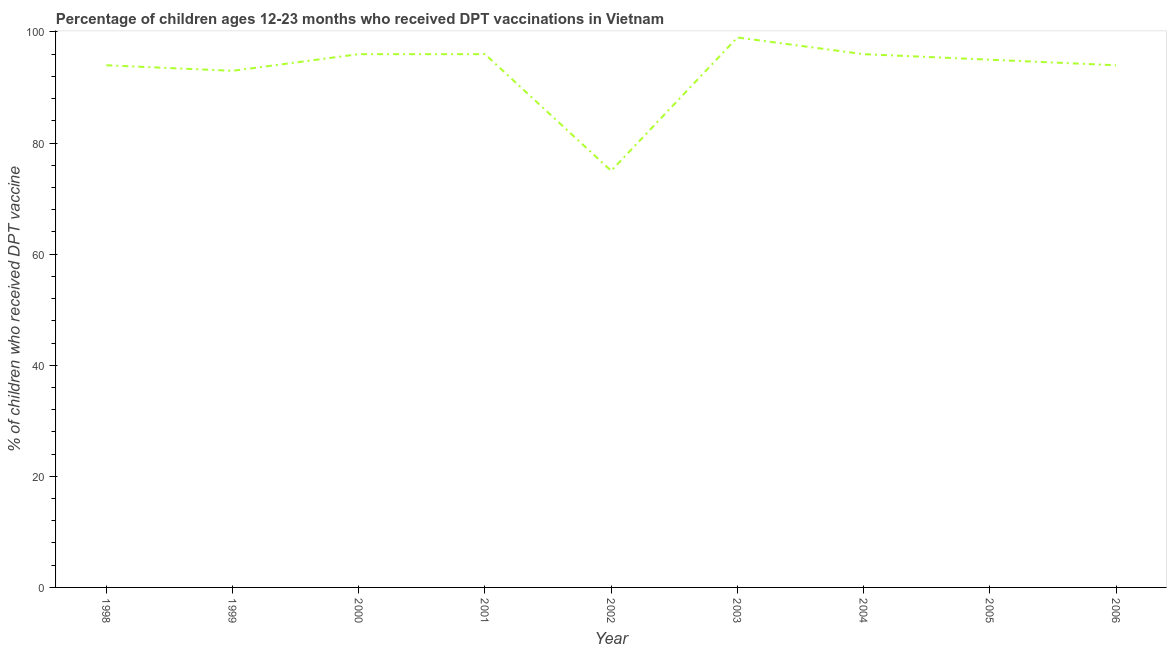What is the percentage of children who received dpt vaccine in 2002?
Offer a very short reply. 75. Across all years, what is the maximum percentage of children who received dpt vaccine?
Provide a short and direct response. 99. Across all years, what is the minimum percentage of children who received dpt vaccine?
Offer a very short reply. 75. In which year was the percentage of children who received dpt vaccine minimum?
Your response must be concise. 2002. What is the sum of the percentage of children who received dpt vaccine?
Keep it short and to the point. 838. What is the difference between the percentage of children who received dpt vaccine in 2001 and 2005?
Your answer should be very brief. 1. What is the average percentage of children who received dpt vaccine per year?
Ensure brevity in your answer.  93.11. What is the ratio of the percentage of children who received dpt vaccine in 1998 to that in 2001?
Your response must be concise. 0.98. Is the percentage of children who received dpt vaccine in 1999 less than that in 2004?
Your response must be concise. Yes. Is the difference between the percentage of children who received dpt vaccine in 2000 and 2002 greater than the difference between any two years?
Give a very brief answer. No. What is the difference between the highest and the second highest percentage of children who received dpt vaccine?
Offer a very short reply. 3. What is the difference between the highest and the lowest percentage of children who received dpt vaccine?
Your answer should be compact. 24. Does the percentage of children who received dpt vaccine monotonically increase over the years?
Ensure brevity in your answer.  No. How many lines are there?
Ensure brevity in your answer.  1. How many years are there in the graph?
Your response must be concise. 9. Are the values on the major ticks of Y-axis written in scientific E-notation?
Provide a short and direct response. No. Does the graph contain any zero values?
Provide a succinct answer. No. Does the graph contain grids?
Provide a short and direct response. No. What is the title of the graph?
Provide a succinct answer. Percentage of children ages 12-23 months who received DPT vaccinations in Vietnam. What is the label or title of the Y-axis?
Keep it short and to the point. % of children who received DPT vaccine. What is the % of children who received DPT vaccine in 1998?
Your answer should be compact. 94. What is the % of children who received DPT vaccine in 1999?
Give a very brief answer. 93. What is the % of children who received DPT vaccine in 2000?
Keep it short and to the point. 96. What is the % of children who received DPT vaccine in 2001?
Your answer should be compact. 96. What is the % of children who received DPT vaccine of 2004?
Make the answer very short. 96. What is the % of children who received DPT vaccine in 2005?
Your answer should be very brief. 95. What is the % of children who received DPT vaccine of 2006?
Give a very brief answer. 94. What is the difference between the % of children who received DPT vaccine in 1998 and 1999?
Provide a succinct answer. 1. What is the difference between the % of children who received DPT vaccine in 1998 and 2000?
Provide a short and direct response. -2. What is the difference between the % of children who received DPT vaccine in 1998 and 2001?
Give a very brief answer. -2. What is the difference between the % of children who received DPT vaccine in 1998 and 2002?
Provide a short and direct response. 19. What is the difference between the % of children who received DPT vaccine in 1998 and 2004?
Provide a succinct answer. -2. What is the difference between the % of children who received DPT vaccine in 1998 and 2006?
Make the answer very short. 0. What is the difference between the % of children who received DPT vaccine in 1999 and 2000?
Ensure brevity in your answer.  -3. What is the difference between the % of children who received DPT vaccine in 1999 and 2001?
Your response must be concise. -3. What is the difference between the % of children who received DPT vaccine in 1999 and 2004?
Give a very brief answer. -3. What is the difference between the % of children who received DPT vaccine in 1999 and 2005?
Provide a short and direct response. -2. What is the difference between the % of children who received DPT vaccine in 1999 and 2006?
Provide a short and direct response. -1. What is the difference between the % of children who received DPT vaccine in 2000 and 2001?
Your answer should be very brief. 0. What is the difference between the % of children who received DPT vaccine in 2000 and 2002?
Make the answer very short. 21. What is the difference between the % of children who received DPT vaccine in 2000 and 2004?
Your answer should be very brief. 0. What is the difference between the % of children who received DPT vaccine in 2001 and 2003?
Your answer should be very brief. -3. What is the difference between the % of children who received DPT vaccine in 2001 and 2005?
Give a very brief answer. 1. What is the difference between the % of children who received DPT vaccine in 2001 and 2006?
Provide a short and direct response. 2. What is the difference between the % of children who received DPT vaccine in 2002 and 2003?
Your answer should be very brief. -24. What is the difference between the % of children who received DPT vaccine in 2002 and 2004?
Your answer should be very brief. -21. What is the difference between the % of children who received DPT vaccine in 2002 and 2005?
Provide a short and direct response. -20. What is the difference between the % of children who received DPT vaccine in 2002 and 2006?
Keep it short and to the point. -19. What is the difference between the % of children who received DPT vaccine in 2003 and 2006?
Provide a succinct answer. 5. What is the difference between the % of children who received DPT vaccine in 2004 and 2005?
Provide a short and direct response. 1. What is the difference between the % of children who received DPT vaccine in 2005 and 2006?
Your answer should be very brief. 1. What is the ratio of the % of children who received DPT vaccine in 1998 to that in 2001?
Give a very brief answer. 0.98. What is the ratio of the % of children who received DPT vaccine in 1998 to that in 2002?
Provide a succinct answer. 1.25. What is the ratio of the % of children who received DPT vaccine in 1998 to that in 2003?
Ensure brevity in your answer.  0.95. What is the ratio of the % of children who received DPT vaccine in 1999 to that in 2001?
Provide a succinct answer. 0.97. What is the ratio of the % of children who received DPT vaccine in 1999 to that in 2002?
Ensure brevity in your answer.  1.24. What is the ratio of the % of children who received DPT vaccine in 1999 to that in 2003?
Your answer should be compact. 0.94. What is the ratio of the % of children who received DPT vaccine in 1999 to that in 2004?
Offer a very short reply. 0.97. What is the ratio of the % of children who received DPT vaccine in 1999 to that in 2006?
Ensure brevity in your answer.  0.99. What is the ratio of the % of children who received DPT vaccine in 2000 to that in 2001?
Provide a succinct answer. 1. What is the ratio of the % of children who received DPT vaccine in 2000 to that in 2002?
Provide a succinct answer. 1.28. What is the ratio of the % of children who received DPT vaccine in 2000 to that in 2003?
Your response must be concise. 0.97. What is the ratio of the % of children who received DPT vaccine in 2000 to that in 2005?
Provide a succinct answer. 1.01. What is the ratio of the % of children who received DPT vaccine in 2000 to that in 2006?
Offer a very short reply. 1.02. What is the ratio of the % of children who received DPT vaccine in 2001 to that in 2002?
Your response must be concise. 1.28. What is the ratio of the % of children who received DPT vaccine in 2001 to that in 2003?
Offer a very short reply. 0.97. What is the ratio of the % of children who received DPT vaccine in 2001 to that in 2004?
Give a very brief answer. 1. What is the ratio of the % of children who received DPT vaccine in 2001 to that in 2006?
Offer a very short reply. 1.02. What is the ratio of the % of children who received DPT vaccine in 2002 to that in 2003?
Offer a terse response. 0.76. What is the ratio of the % of children who received DPT vaccine in 2002 to that in 2004?
Ensure brevity in your answer.  0.78. What is the ratio of the % of children who received DPT vaccine in 2002 to that in 2005?
Make the answer very short. 0.79. What is the ratio of the % of children who received DPT vaccine in 2002 to that in 2006?
Offer a terse response. 0.8. What is the ratio of the % of children who received DPT vaccine in 2003 to that in 2004?
Offer a terse response. 1.03. What is the ratio of the % of children who received DPT vaccine in 2003 to that in 2005?
Ensure brevity in your answer.  1.04. What is the ratio of the % of children who received DPT vaccine in 2003 to that in 2006?
Offer a very short reply. 1.05. What is the ratio of the % of children who received DPT vaccine in 2004 to that in 2005?
Your response must be concise. 1.01. What is the ratio of the % of children who received DPT vaccine in 2004 to that in 2006?
Give a very brief answer. 1.02. What is the ratio of the % of children who received DPT vaccine in 2005 to that in 2006?
Provide a short and direct response. 1.01. 